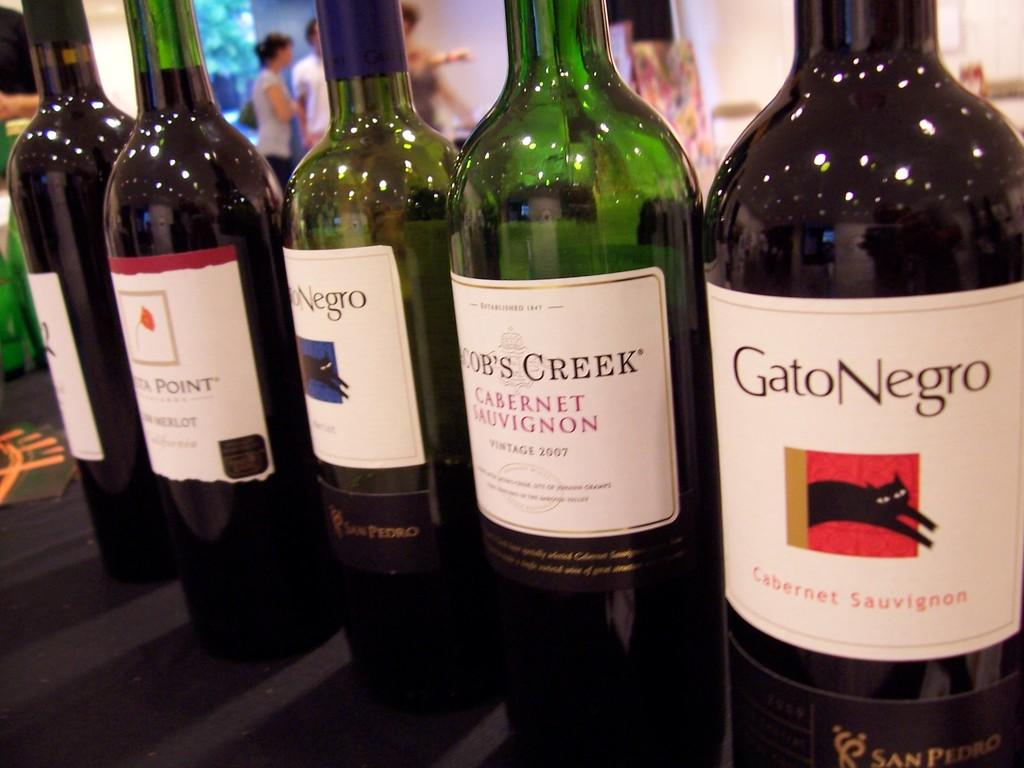<image>
Share a concise interpretation of the image provided. many bottles of wine lined up include Gato Negro 